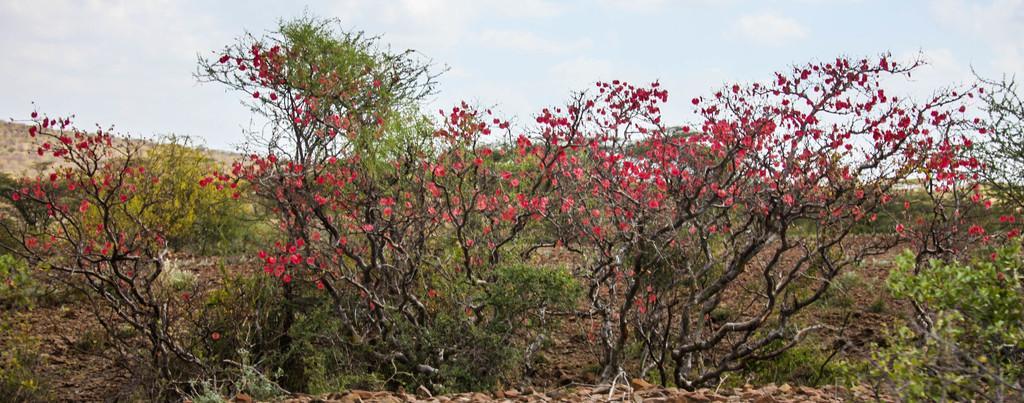Please provide a concise description of this image. In this picture, there are trees and these trees have flowers which are in red color. In the background, we see the sky. 